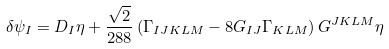Convert formula to latex. <formula><loc_0><loc_0><loc_500><loc_500>\delta \psi _ { I } = D _ { I } \eta + \frac { \sqrt { 2 } } { 2 8 8 } \left ( \Gamma _ { I J K L M } - 8 G _ { I J } \Gamma _ { K L M } \right ) G ^ { J K L M } \eta</formula> 